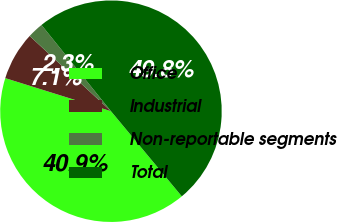Convert chart to OTSL. <chart><loc_0><loc_0><loc_500><loc_500><pie_chart><fcel>Office<fcel>Industrial<fcel>Non-reportable segments<fcel>Total<nl><fcel>40.87%<fcel>7.06%<fcel>2.32%<fcel>49.75%<nl></chart> 